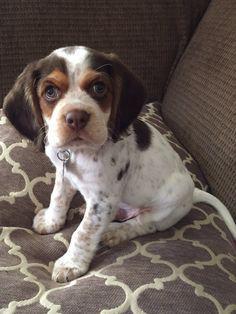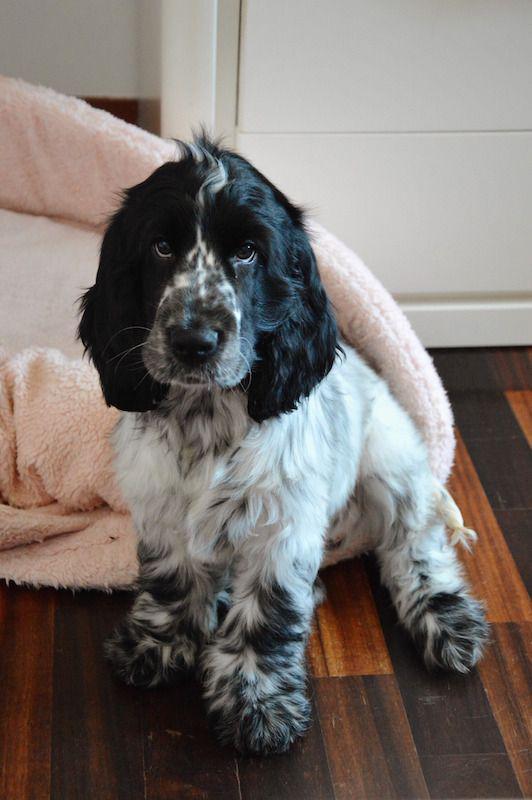The first image is the image on the left, the second image is the image on the right. Examine the images to the left and right. Is the description "In one of the images, a human hand can be seen touching a single dog." accurate? Answer yes or no. No. The first image is the image on the left, the second image is the image on the right. Evaluate the accuracy of this statement regarding the images: "An image contains a human holding a dog.". Is it true? Answer yes or no. No. 